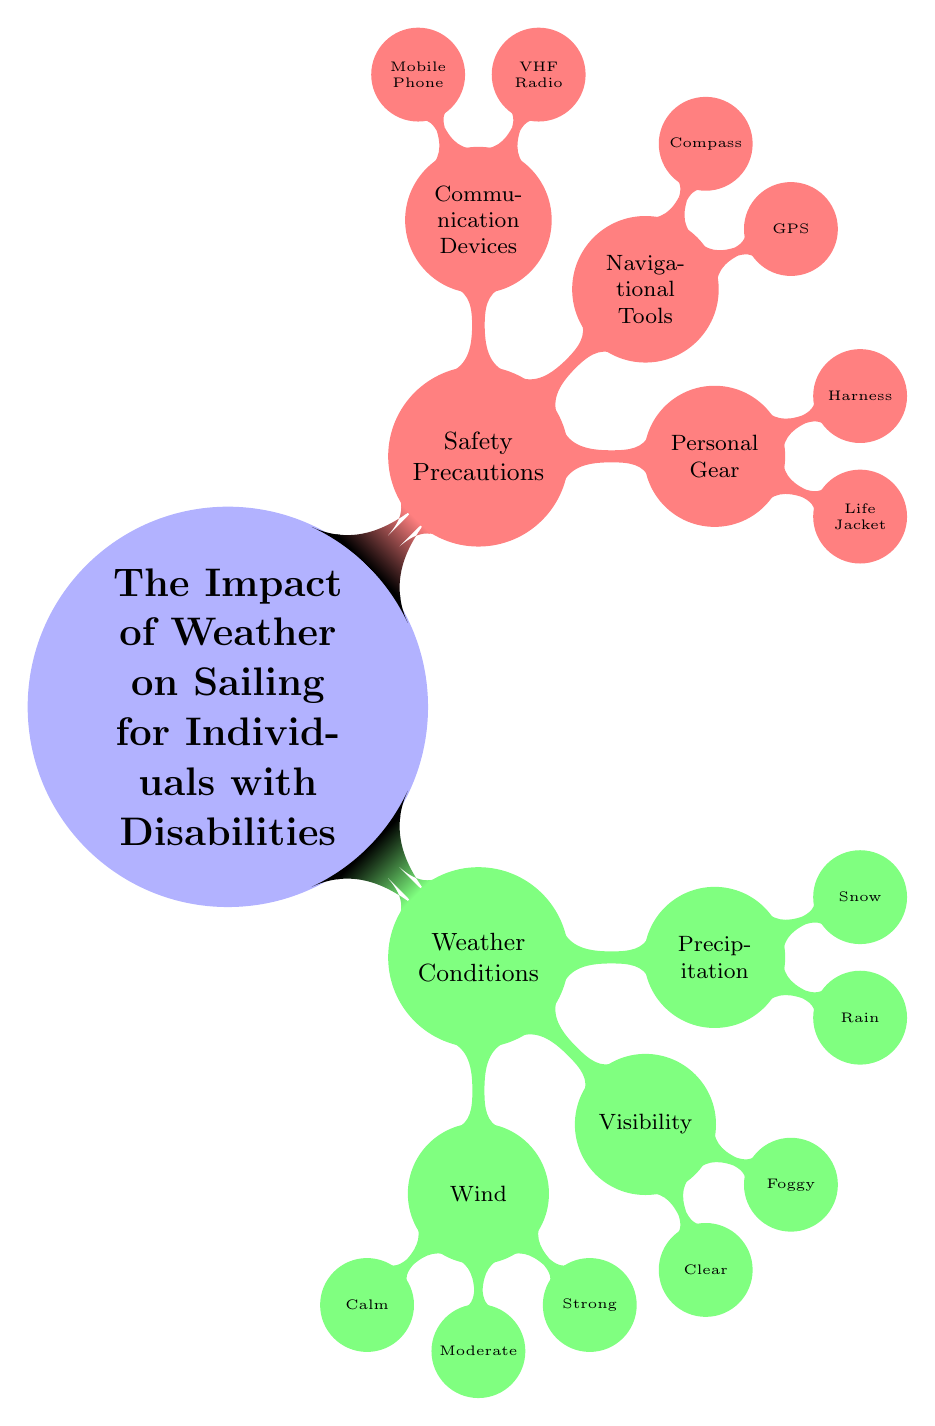What are the three weather conditions listed? The diagram lists three weather conditions under the "Weather Conditions" category. These are "Wind," "Visibility," and "Precipitation."
Answer: Wind, Visibility, Precipitation How many types of personal gear are mentioned? The section on "Personal Gear" consists of two items: "Life Jacket" and "Harness." Counting these, we find there are two types of personal gear mentioned.
Answer: 2 What type of navigational tool is specified? Navigate to the "Navigational Tools" node, and the diagram indicates two specific tools: "GPS" and "Compass." Here, "GPS" is one of the specified types.
Answer: GPS Which weather condition corresponds to limited visibility? The diagram includes a weather condition listed under "Visibility," which is "Foggy." This condition is known for limited visibility on water.
Answer: Foggy Which safety precaution includes communication devices? The "Safety Precautions" section includes a part labeled "Communication Devices." This indicates that communication devices are considered a vital safety precaution category.
Answer: Communication Devices How many types of precipitation are mentioned? Under the "Precipitation" category in the diagram, we see two types: "Rain" and "Snow." Thus, there are two types of precipitation noted.
Answer: 2 What is the color associated with safety precautions? In the diagram, the section labeled "Safety Precautions" is represented in red!50, which is the associated color for this category.
Answer: Red Explain the relationship between visibility and precipitation in the diagram. The diagram illustrates "Visibility" and "Precipitation" as separate but significant weather conditions influencing sailing, implying that both can affect sailing conditions independently and potentially interact; for instance, fog can result from precipitation.
Answer: Independent relationship What type of communication device is listed? The "Communication Devices" branch specifies two types of devices: "VHF Radio" and "Mobile Phone." Here, "VHF Radio" is one type mentioned in the diagram.
Answer: VHF Radio 